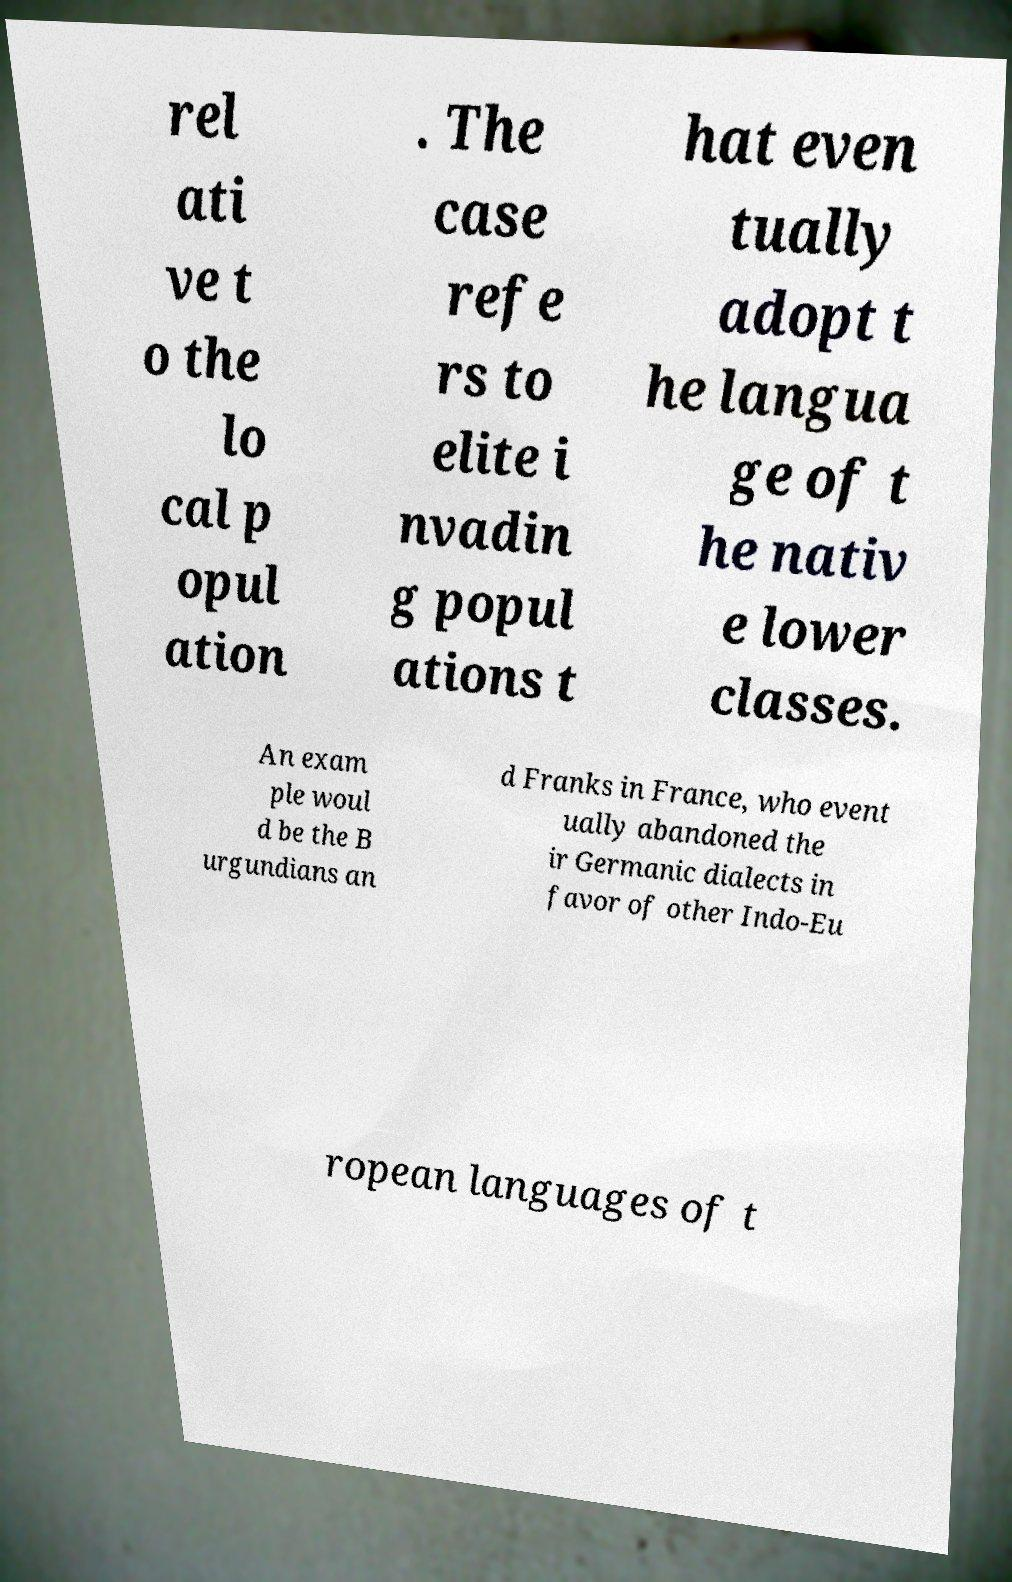Please read and relay the text visible in this image. What does it say? rel ati ve t o the lo cal p opul ation . The case refe rs to elite i nvadin g popul ations t hat even tually adopt t he langua ge of t he nativ e lower classes. An exam ple woul d be the B urgundians an d Franks in France, who event ually abandoned the ir Germanic dialects in favor of other Indo-Eu ropean languages of t 